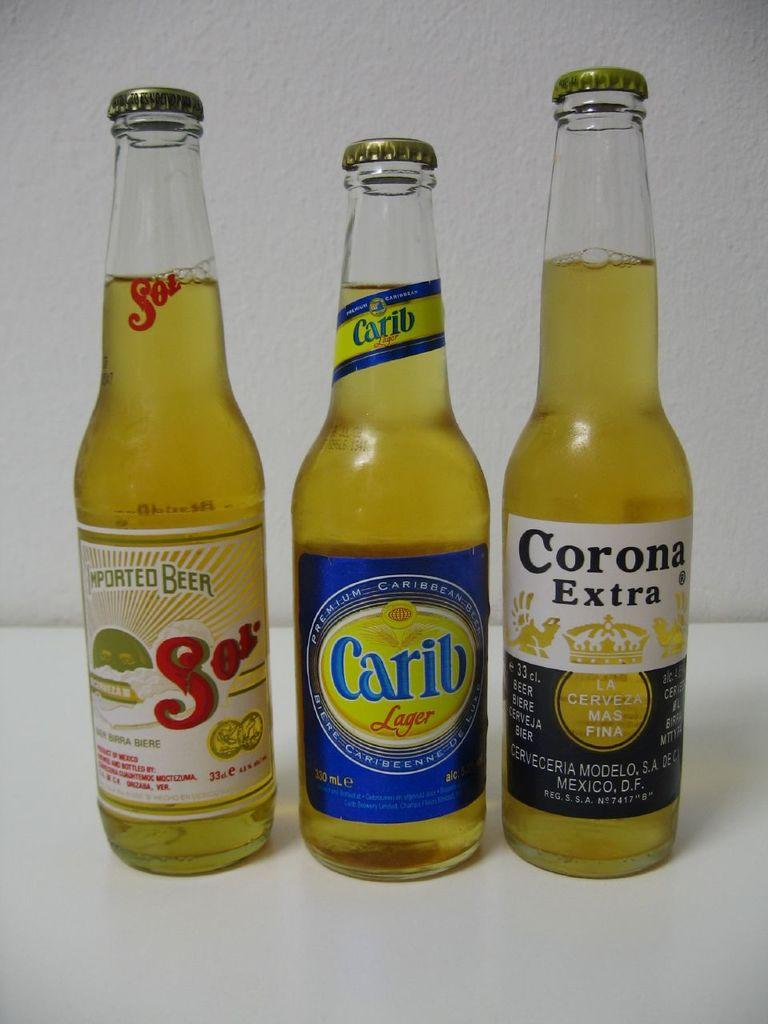How many bottles are visible in the image? There are three bottles in the image. Are the bottles opened or closed? None of the bottles are opened. What color is the liquid inside the bottles? The liquid inside the bottles is yellow in color. How can the contents of the bottles be identified? The bottles are labelled and have text written on them. What type of insect can be seen crawling on the badge in the image? There is no insect or badge present in the image. What type of trade is being conducted in the image? There is no trade being conducted in the image; it only features three bottles with yellow liquid. 